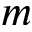<formula> <loc_0><loc_0><loc_500><loc_500>m</formula> 